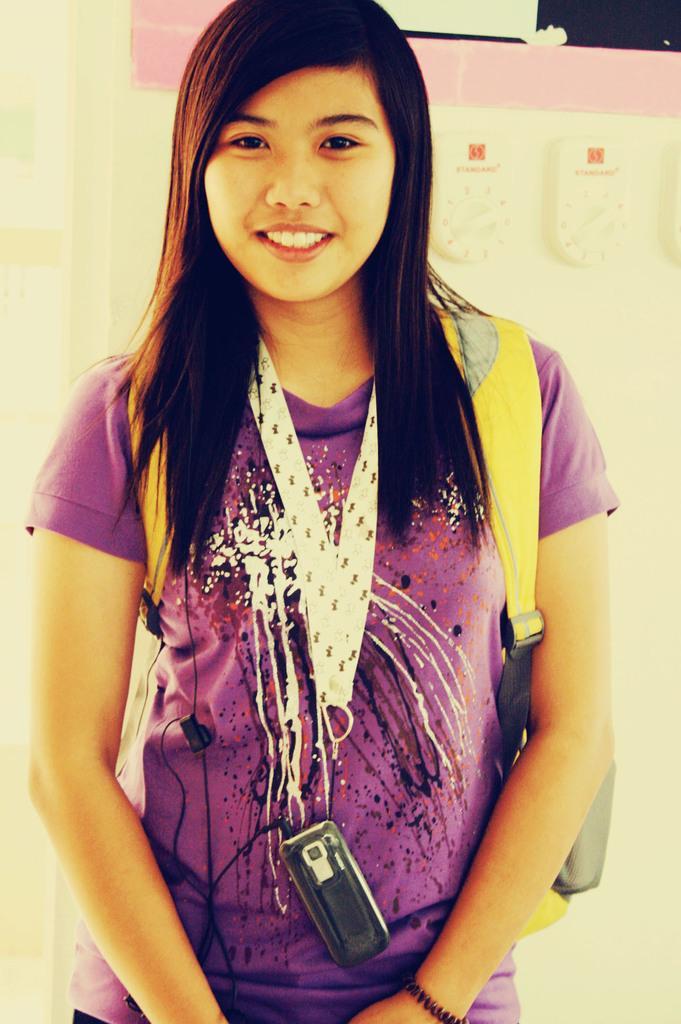How would you summarize this image in a sentence or two? In this picture I can see a woman standing and smiling. I can see a mobile hanging with a tag around her neck, and in the background there are some objects. 